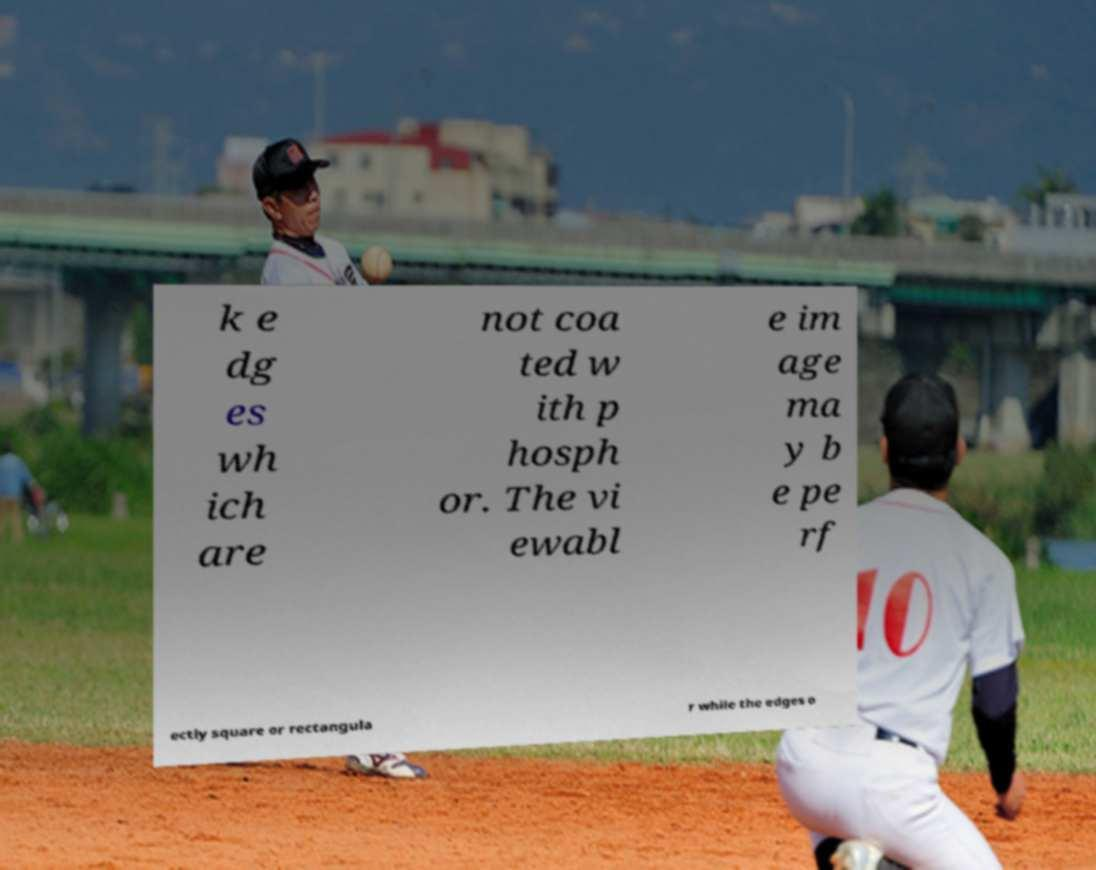Please identify and transcribe the text found in this image. k e dg es wh ich are not coa ted w ith p hosph or. The vi ewabl e im age ma y b e pe rf ectly square or rectangula r while the edges o 